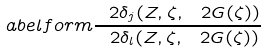Convert formula to latex. <formula><loc_0><loc_0><loc_500><loc_500>\L a b e l { f o r m } \frac { \ 2 { \delta _ { j } } ( Z , \zeta , \ 2 G ( \zeta ) ) } { \ 2 { \delta _ { l } } ( Z , \zeta , \ 2 G ( \zeta ) ) }</formula> 